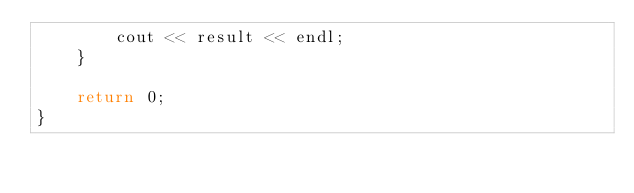<code> <loc_0><loc_0><loc_500><loc_500><_C++_>        cout << result << endl;
    }

    return 0;
}
</code> 